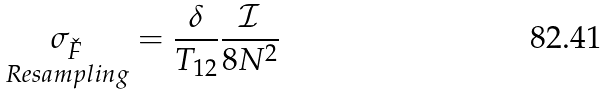Convert formula to latex. <formula><loc_0><loc_0><loc_500><loc_500>\underset { R e s a m p l i n g } { \sigma _ { \check { F } } } = \frac { \delta } { T _ { 1 2 } } \frac { \mathcal { I } } { 8 N ^ { 2 } }</formula> 